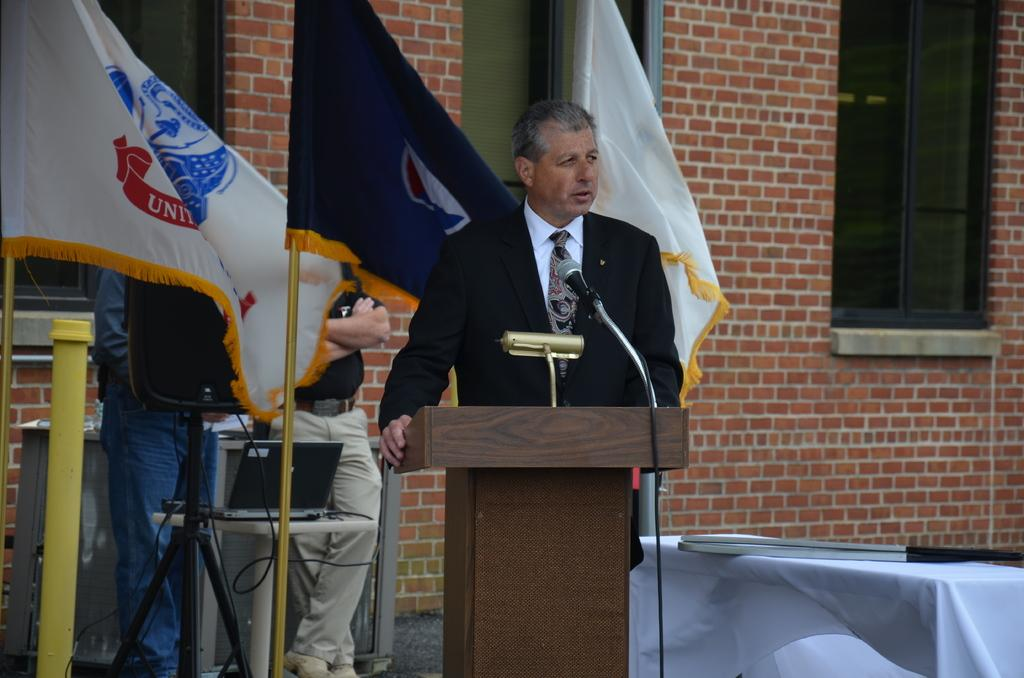What type of structure can be seen in the image? There is a brick wall in the image. What architectural feature is present in the brick wall? There is a window in the image. What piece of furniture is visible in the image? There is a table in the image. What decorative items are present in the image? There are flags in the image. How many people are in the image? There are three people standing in the image. What equipment is being used in the image? There is a mic in the image. What electronic device is present in the image? There is a laptop in the image. Can you tell me how many beads are on the cow in the image? There is no cow or beads present in the image. What type of lamp is being used by the people in the image? There is no lamp present in the image. 